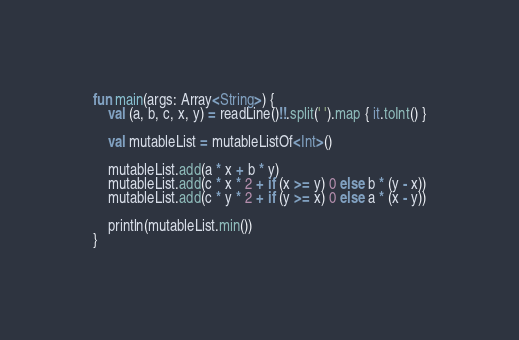Convert code to text. <code><loc_0><loc_0><loc_500><loc_500><_Kotlin_>fun main(args: Array<String>) {
    val (a, b, c, x, y) = readLine()!!.split(' ').map { it.toInt() }

    val mutableList = mutableListOf<Int>()

    mutableList.add(a * x + b * y)
    mutableList.add(c * x * 2 + if (x >= y) 0 else b * (y - x))
    mutableList.add(c * y * 2 + if (y >= x) 0 else a * (x - y))

    println(mutableList.min())
}
</code> 